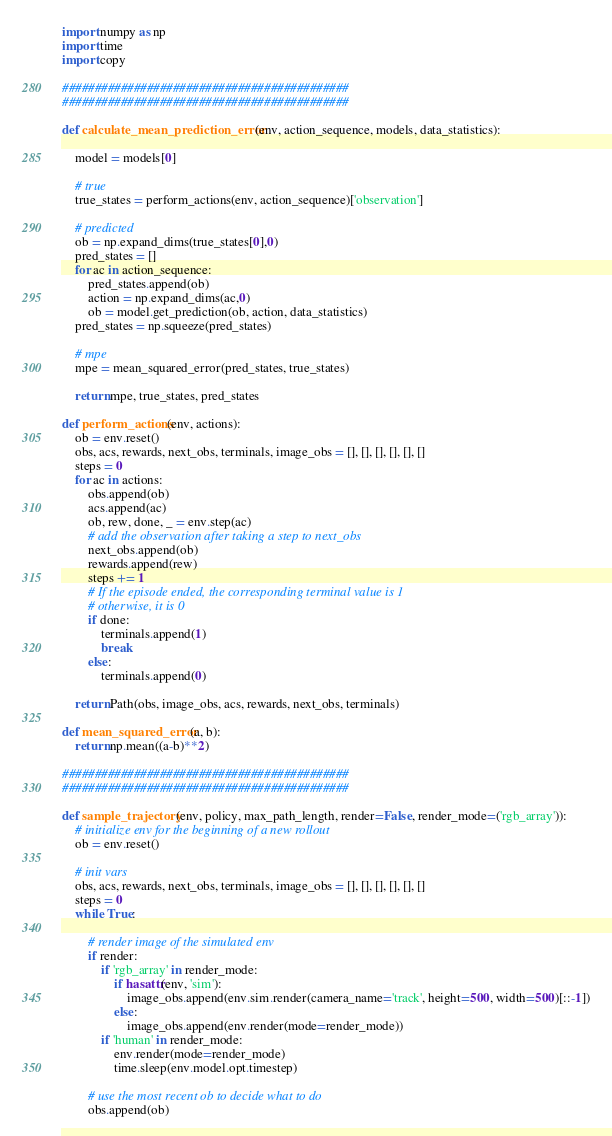<code> <loc_0><loc_0><loc_500><loc_500><_Python_>import numpy as np
import time
import copy

############################################
############################################

def calculate_mean_prediction_error(env, action_sequence, models, data_statistics):

    model = models[0]

    # true
    true_states = perform_actions(env, action_sequence)['observation']

    # predicted
    ob = np.expand_dims(true_states[0],0)
    pred_states = []
    for ac in action_sequence:
        pred_states.append(ob)
        action = np.expand_dims(ac,0)
        ob = model.get_prediction(ob, action, data_statistics)
    pred_states = np.squeeze(pred_states)

    # mpe
    mpe = mean_squared_error(pred_states, true_states)

    return mpe, true_states, pred_states

def perform_actions(env, actions):
    ob = env.reset()
    obs, acs, rewards, next_obs, terminals, image_obs = [], [], [], [], [], []
    steps = 0
    for ac in actions:
        obs.append(ob)
        acs.append(ac)
        ob, rew, done, _ = env.step(ac)
        # add the observation after taking a step to next_obs
        next_obs.append(ob)
        rewards.append(rew)
        steps += 1
        # If the episode ended, the corresponding terminal value is 1
        # otherwise, it is 0
        if done:
            terminals.append(1)
            break
        else:
            terminals.append(0)

    return Path(obs, image_obs, acs, rewards, next_obs, terminals)

def mean_squared_error(a, b):
    return np.mean((a-b)**2)

############################################
############################################

def sample_trajectory(env, policy, max_path_length, render=False, render_mode=('rgb_array')):
    # initialize env for the beginning of a new rollout
    ob = env.reset()

    # init vars
    obs, acs, rewards, next_obs, terminals, image_obs = [], [], [], [], [], []
    steps = 0
    while True:

        # render image of the simulated env
        if render:
            if 'rgb_array' in render_mode:
                if hasattr(env, 'sim'):
                    image_obs.append(env.sim.render(camera_name='track', height=500, width=500)[::-1])
                else:
                    image_obs.append(env.render(mode=render_mode))
            if 'human' in render_mode:
                env.render(mode=render_mode)
                time.sleep(env.model.opt.timestep)

        # use the most recent ob to decide what to do
        obs.append(ob)</code> 